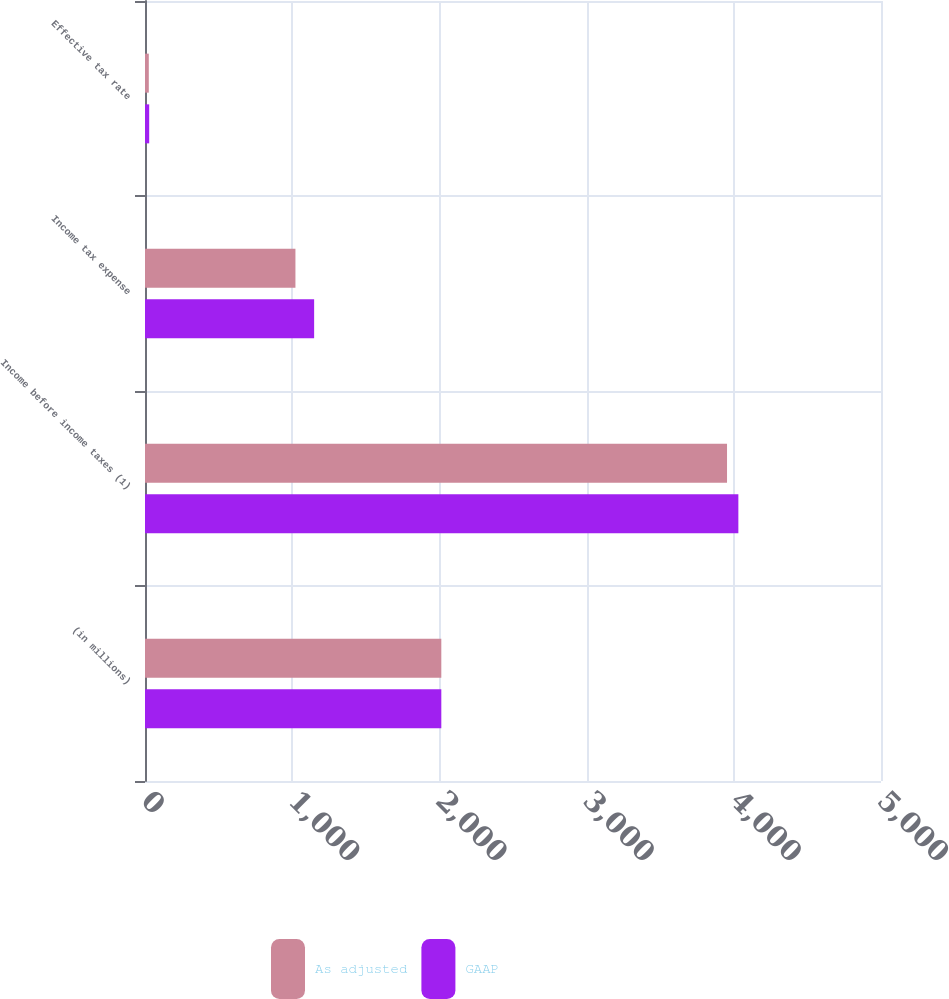<chart> <loc_0><loc_0><loc_500><loc_500><stacked_bar_chart><ecel><fcel>(in millions)<fcel>Income before income taxes (1)<fcel>Income tax expense<fcel>Effective tax rate<nl><fcel>As adjusted<fcel>2013<fcel>3954<fcel>1022<fcel>25.8<nl><fcel>GAAP<fcel>2013<fcel>4031<fcel>1149<fcel>28.5<nl></chart> 